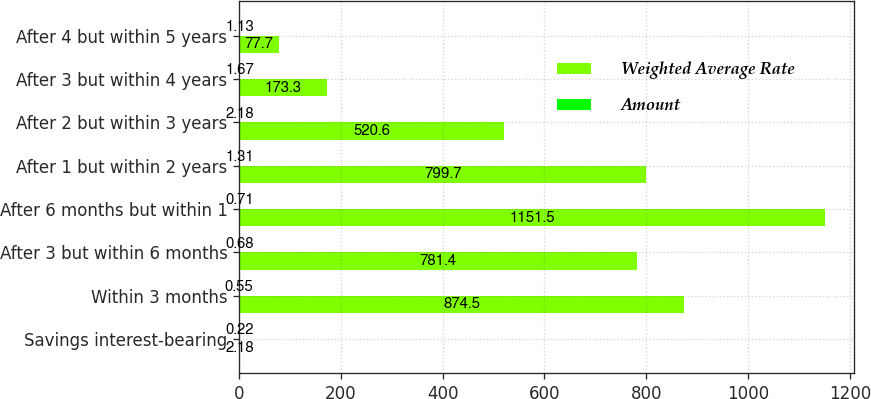<chart> <loc_0><loc_0><loc_500><loc_500><stacked_bar_chart><ecel><fcel>Savings interest-bearing<fcel>Within 3 months<fcel>After 3 but within 6 months<fcel>After 6 months but within 1<fcel>After 1 but within 2 years<fcel>After 2 but within 3 years<fcel>After 3 but within 4 years<fcel>After 4 but within 5 years<nl><fcel>Weighted Average Rate<fcel>2.18<fcel>874.5<fcel>781.4<fcel>1151.5<fcel>799.7<fcel>520.6<fcel>173.3<fcel>77.7<nl><fcel>Amount<fcel>0.22<fcel>0.55<fcel>0.68<fcel>0.71<fcel>1.31<fcel>2.18<fcel>1.67<fcel>1.13<nl></chart> 